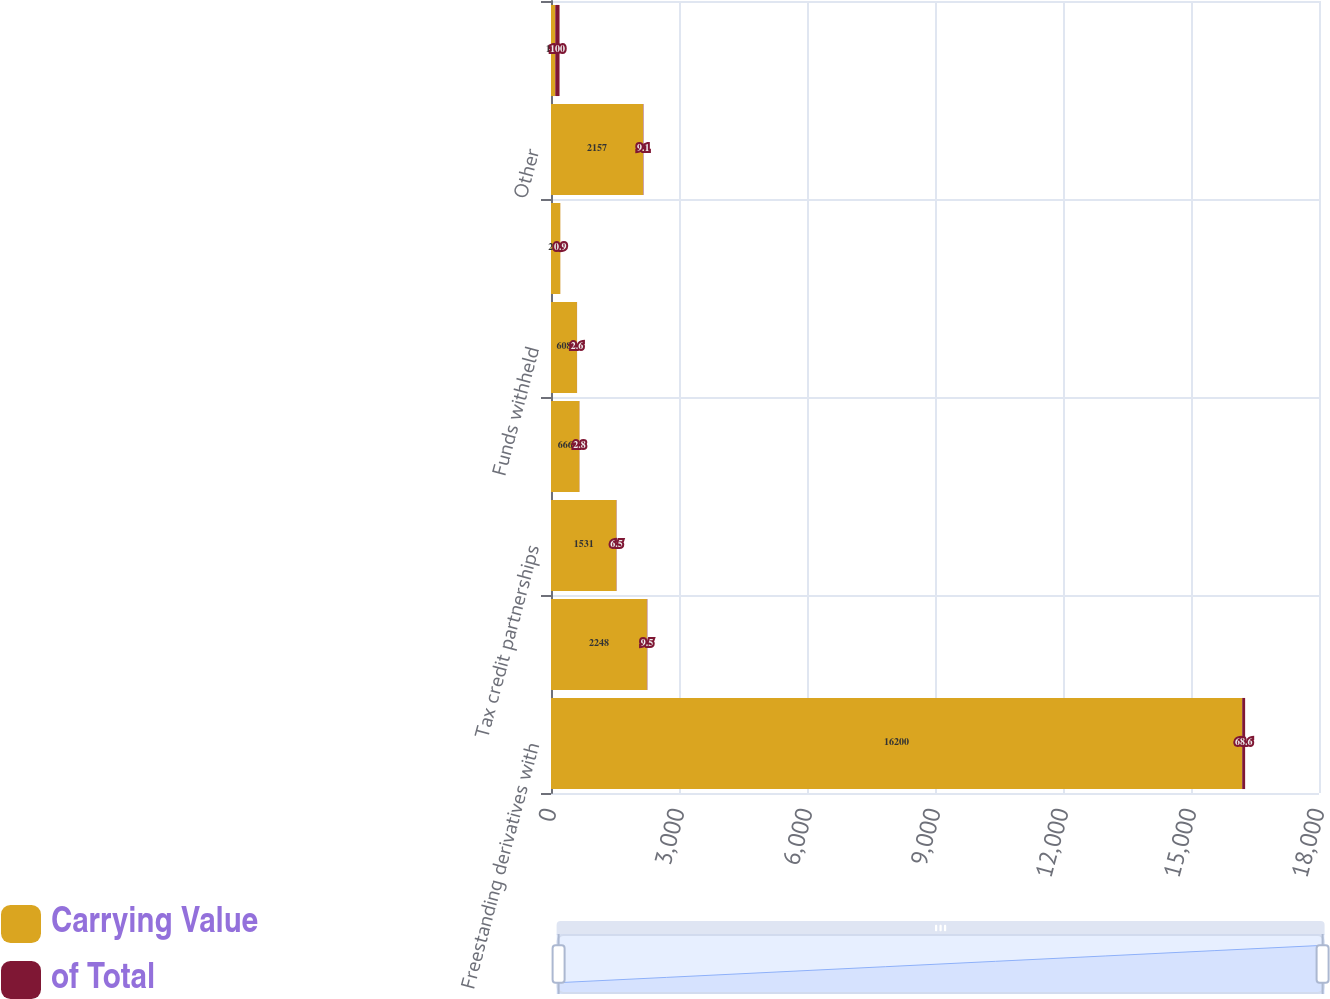Convert chart to OTSL. <chart><loc_0><loc_0><loc_500><loc_500><stacked_bar_chart><ecel><fcel>Freestanding derivatives with<fcel>Leveraged leases net of<fcel>Tax credit partnerships<fcel>MSRs<fcel>Funds withheld<fcel>Joint venture investments<fcel>Other<fcel>Total<nl><fcel>Carrying Value<fcel>16200<fcel>2248<fcel>1531<fcel>666<fcel>608<fcel>218<fcel>2157<fcel>100<nl><fcel>of Total<fcel>68.6<fcel>9.5<fcel>6.5<fcel>2.8<fcel>2.6<fcel>0.9<fcel>9.1<fcel>100<nl></chart> 